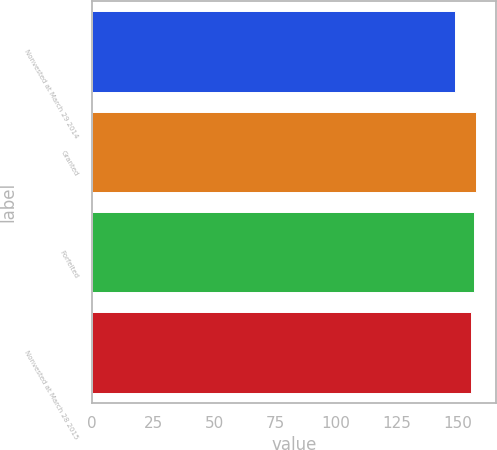<chart> <loc_0><loc_0><loc_500><loc_500><bar_chart><fcel>Nonvested at March 29 2014<fcel>Granted<fcel>Forfeited<fcel>Nonvested at March 28 2015<nl><fcel>148.93<fcel>157.54<fcel>156.72<fcel>155.47<nl></chart> 